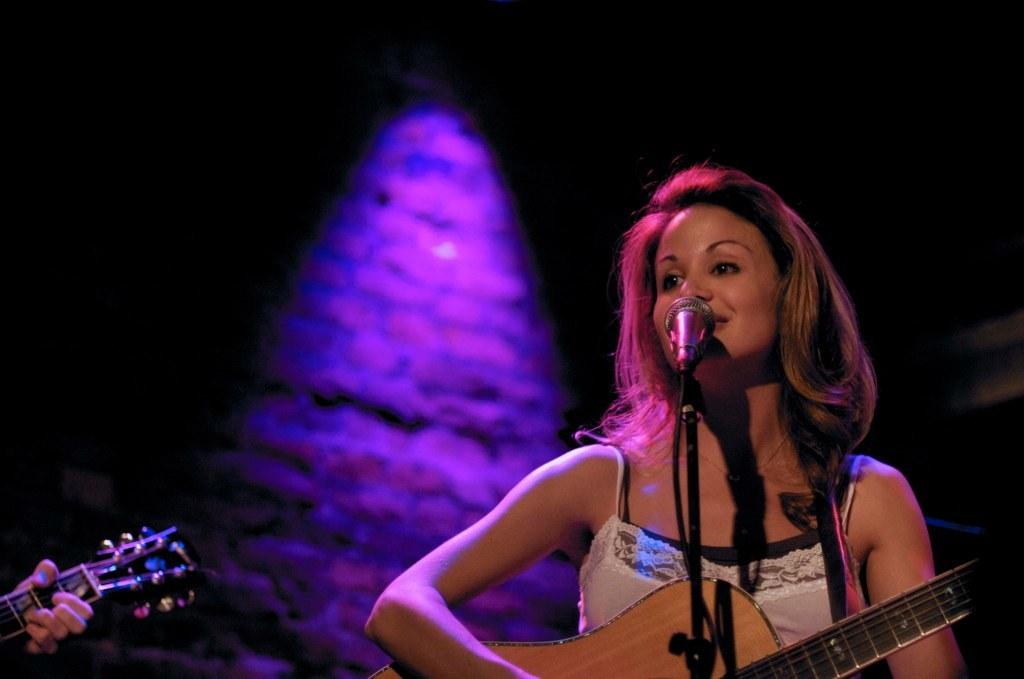Who is the main subject in the image? There is a lady in the image. Where is the lady positioned in the image? The lady is standing at the right side of the image. What is the lady holding in her hand? The lady is holding a guitar in her hand. What object is in front of the lady? There is a microphone (mic) in front of her. What type of turkey is being prepared in the image? There is no turkey present in the image; it features a lady holding a guitar and standing near a microphone. 